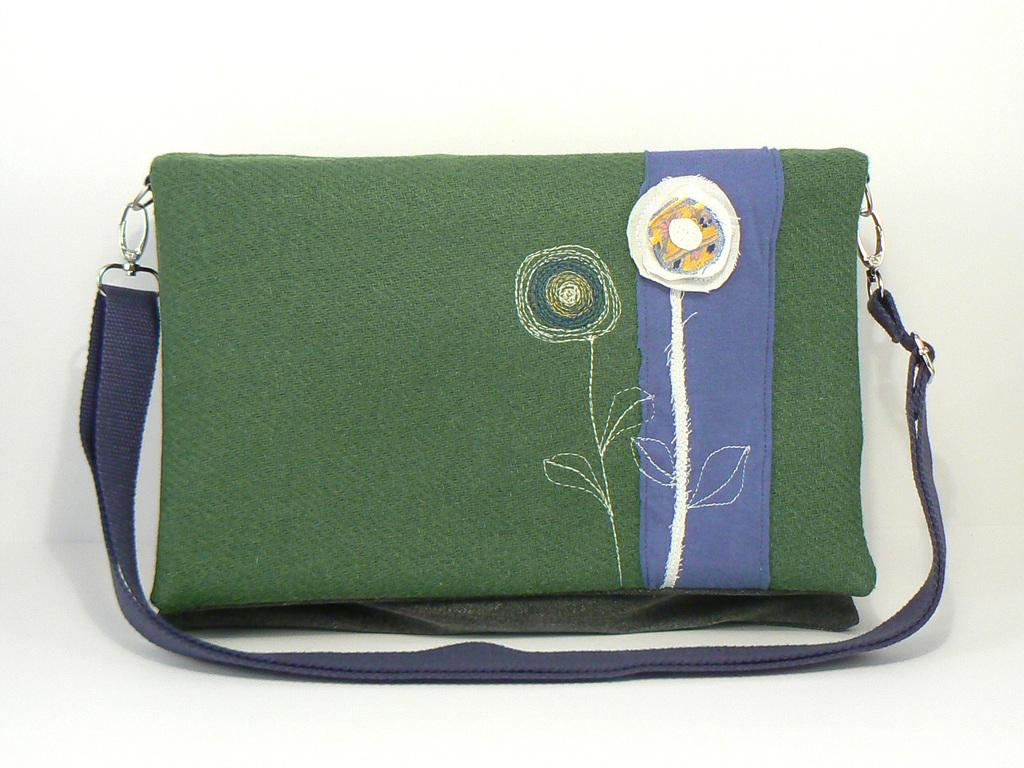What object can be seen in the image? There is a bag in the image. What is unique about the bag? There is a handmade flower on the bag. How many rabbits are sitting on the legs of the bag in the image? There are no rabbits or legs present in the image; it only features a bag with a handmade flower. 